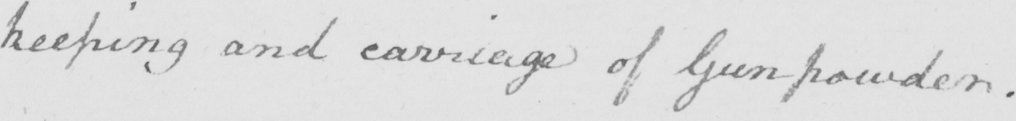Please provide the text content of this handwritten line. keeping and carriage of Gunpowder . 